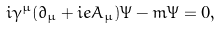Convert formula to latex. <formula><loc_0><loc_0><loc_500><loc_500>i \gamma ^ { \mu } ( \partial _ { \mu } + i e A _ { \mu } ) \Psi - m \Psi = 0 ,</formula> 